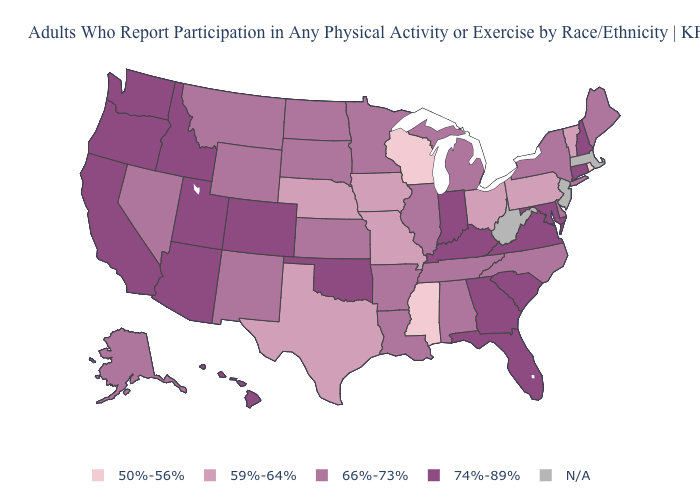What is the highest value in the South ?
Quick response, please. 74%-89%. Name the states that have a value in the range 50%-56%?
Give a very brief answer. Mississippi, Rhode Island, Wisconsin. Name the states that have a value in the range 50%-56%?
Short answer required. Mississippi, Rhode Island, Wisconsin. What is the highest value in the Northeast ?
Answer briefly. 74%-89%. What is the value of North Carolina?
Keep it brief. 66%-73%. What is the value of South Carolina?
Write a very short answer. 74%-89%. Name the states that have a value in the range 59%-64%?
Be succinct. Iowa, Missouri, Nebraska, Ohio, Pennsylvania, Texas, Vermont. Does the first symbol in the legend represent the smallest category?
Write a very short answer. Yes. Which states have the highest value in the USA?
Write a very short answer. Arizona, California, Colorado, Connecticut, Florida, Georgia, Hawaii, Idaho, Indiana, Kentucky, Maryland, New Hampshire, Oklahoma, Oregon, South Carolina, Utah, Virginia, Washington. What is the value of Nebraska?
Keep it brief. 59%-64%. Does the first symbol in the legend represent the smallest category?
Answer briefly. Yes. What is the highest value in the USA?
Be succinct. 74%-89%. Name the states that have a value in the range 66%-73%?
Write a very short answer. Alabama, Alaska, Arkansas, Delaware, Illinois, Kansas, Louisiana, Maine, Michigan, Minnesota, Montana, Nevada, New Mexico, New York, North Carolina, North Dakota, South Dakota, Tennessee, Wyoming. What is the value of Mississippi?
Give a very brief answer. 50%-56%. 